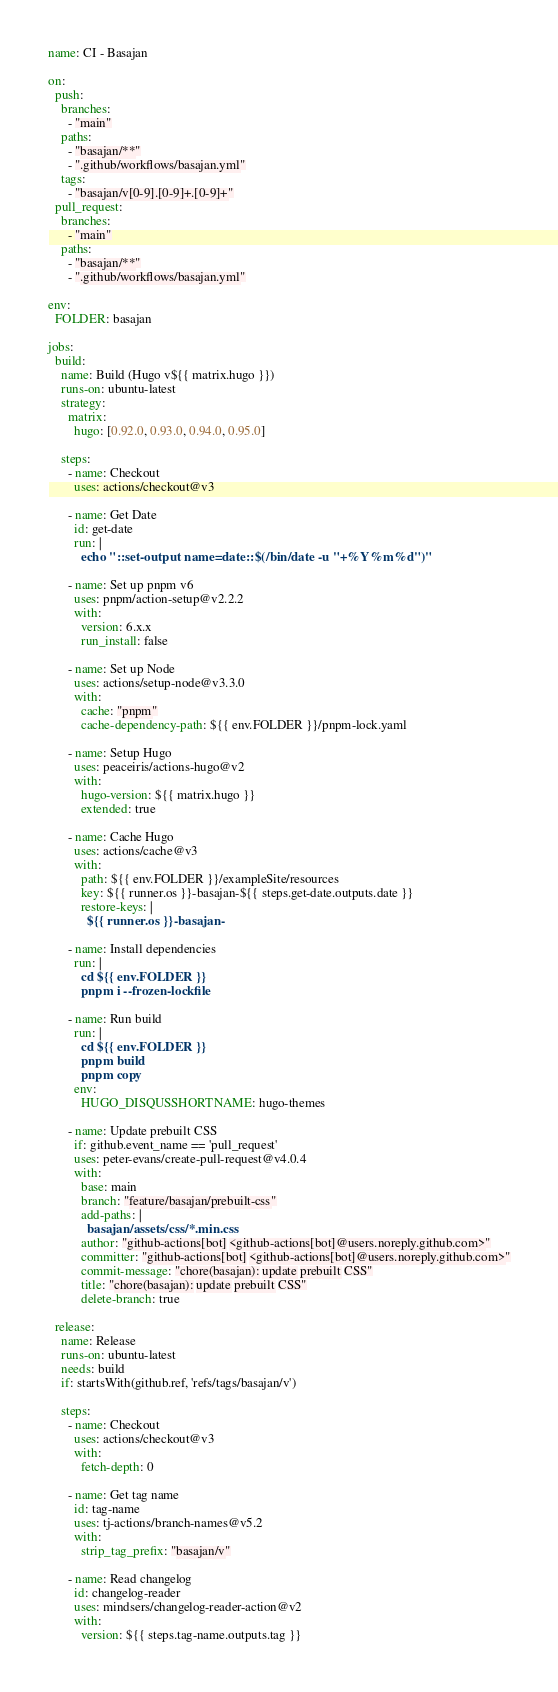Convert code to text. <code><loc_0><loc_0><loc_500><loc_500><_YAML_>name: CI - Basajan

on:
  push:
    branches:
      - "main"
    paths:
      - "basajan/**"
      - ".github/workflows/basajan.yml"
    tags:
      - "basajan/v[0-9].[0-9]+.[0-9]+"
  pull_request:
    branches:
      - "main"
    paths:
      - "basajan/**"
      - ".github/workflows/basajan.yml"

env:
  FOLDER: basajan

jobs:
  build:
    name: Build (Hugo v${{ matrix.hugo }})
    runs-on: ubuntu-latest
    strategy:
      matrix:
        hugo: [0.92.0, 0.93.0, 0.94.0, 0.95.0]

    steps:
      - name: Checkout
        uses: actions/checkout@v3

      - name: Get Date
        id: get-date
        run: |
          echo "::set-output name=date::$(/bin/date -u "+%Y%m%d")"

      - name: Set up pnpm v6
        uses: pnpm/action-setup@v2.2.2
        with:
          version: 6.x.x
          run_install: false

      - name: Set up Node
        uses: actions/setup-node@v3.3.0
        with:
          cache: "pnpm"
          cache-dependency-path: ${{ env.FOLDER }}/pnpm-lock.yaml

      - name: Setup Hugo
        uses: peaceiris/actions-hugo@v2
        with:
          hugo-version: ${{ matrix.hugo }}
          extended: true

      - name: Cache Hugo
        uses: actions/cache@v3
        with:
          path: ${{ env.FOLDER }}/exampleSite/resources
          key: ${{ runner.os }}-basajan-${{ steps.get-date.outputs.date }}
          restore-keys: |
            ${{ runner.os }}-basajan-

      - name: Install dependencies
        run: |
          cd ${{ env.FOLDER }}
          pnpm i --frozen-lockfile

      - name: Run build
        run: |
          cd ${{ env.FOLDER }}
          pnpm build
          pnpm copy
        env:
          HUGO_DISQUSSHORTNAME: hugo-themes
  
      - name: Update prebuilt CSS
        if: github.event_name == 'pull_request'
        uses: peter-evans/create-pull-request@v4.0.4
        with:
          base: main
          branch: "feature/basajan/prebuilt-css"
          add-paths: |
            basajan/assets/css/*.min.css
          author: "github-actions[bot] <github-actions[bot]@users.noreply.github.com>"
          committer: "github-actions[bot] <github-actions[bot]@users.noreply.github.com>"
          commit-message: "chore(basajan): update prebuilt CSS"
          title: "chore(basajan): update prebuilt CSS"
          delete-branch: true
      
  release:
    name: Release
    runs-on: ubuntu-latest
    needs: build
    if: startsWith(github.ref, 'refs/tags/basajan/v')

    steps:
      - name: Checkout
        uses: actions/checkout@v3
        with:
          fetch-depth: 0

      - name: Get tag name
        id: tag-name
        uses: tj-actions/branch-names@v5.2
        with:
          strip_tag_prefix: "basajan/v"

      - name: Read changelog
        id: changelog-reader
        uses: mindsers/changelog-reader-action@v2
        with:
          version: ${{ steps.tag-name.outputs.tag }}</code> 